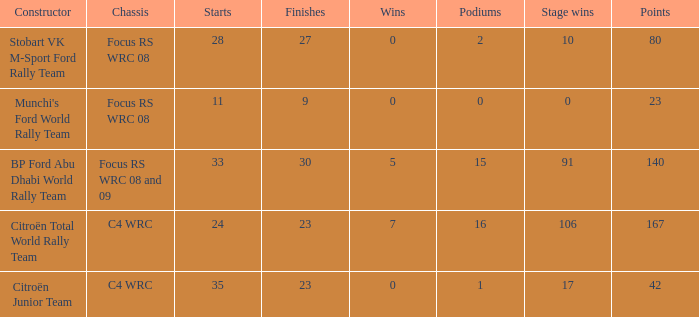Help me parse the entirety of this table. {'header': ['Constructor', 'Chassis', 'Starts', 'Finishes', 'Wins', 'Podiums', 'Stage wins', 'Points'], 'rows': [['Stobart VK M-Sport Ford Rally Team', 'Focus RS WRC 08', '28', '27', '0', '2', '10', '80'], ["Munchi's Ford World Rally Team", 'Focus RS WRC 08', '11', '9', '0', '0', '0', '23'], ['BP Ford Abu Dhabi World Rally Team', 'Focus RS WRC 08 and 09', '33', '30', '5', '15', '91', '140'], ['Citroën Total World Rally Team', 'C4 WRC', '24', '23', '7', '16', '106', '167'], ['Citroën Junior Team', 'C4 WRC', '35', '23', '0', '1', '17', '42']]} What is the average wins when the podiums is more than 1, points is 80 and starts is less than 28? None. 